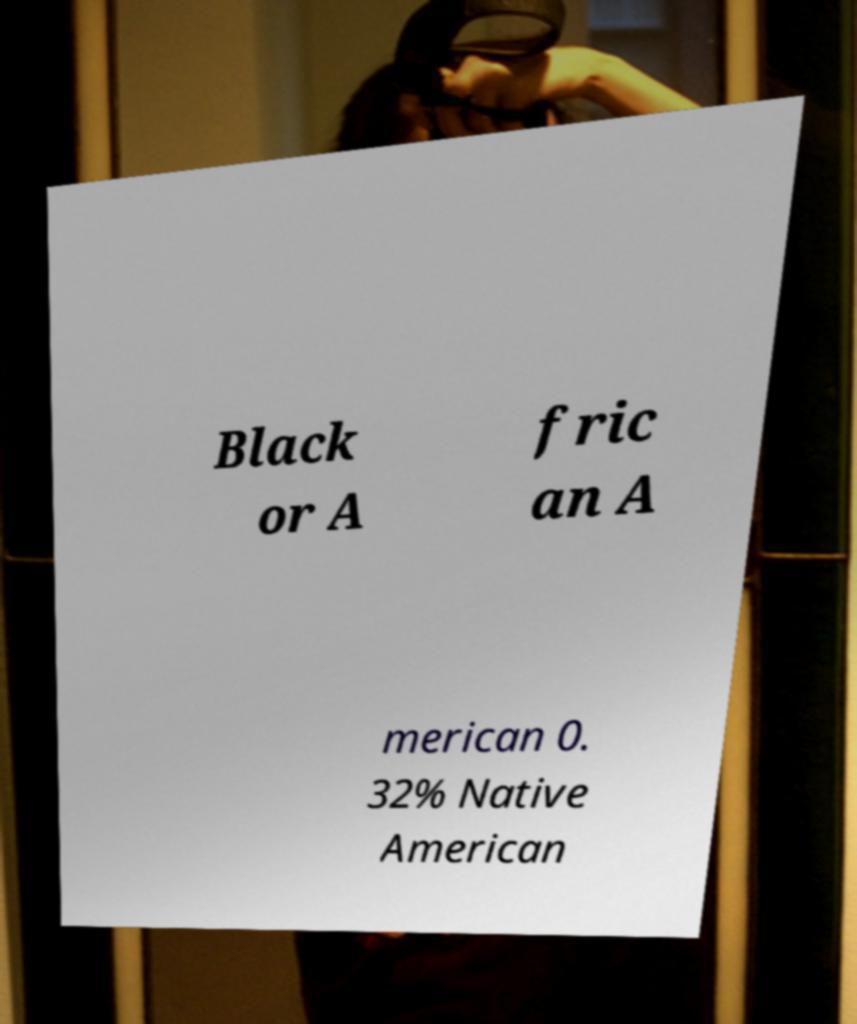For documentation purposes, I need the text within this image transcribed. Could you provide that? Black or A fric an A merican 0. 32% Native American 